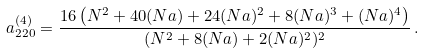Convert formula to latex. <formula><loc_0><loc_0><loc_500><loc_500>a _ { 2 2 0 } ^ { ( 4 ) } = \frac { 1 6 \left ( N ^ { 2 } + 4 0 ( N a ) + 2 4 ( N a ) ^ { 2 } + 8 ( N a ) ^ { 3 } + ( N a ) ^ { 4 } \right ) } { ( N ^ { 2 } + 8 ( N a ) + 2 ( N a ) ^ { 2 } ) ^ { 2 } } \, .</formula> 